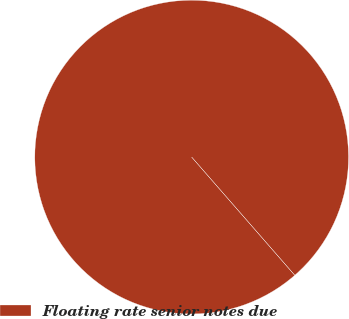Convert chart. <chart><loc_0><loc_0><loc_500><loc_500><pie_chart><fcel>Floating rate senior notes due<nl><fcel>100.0%<nl></chart> 